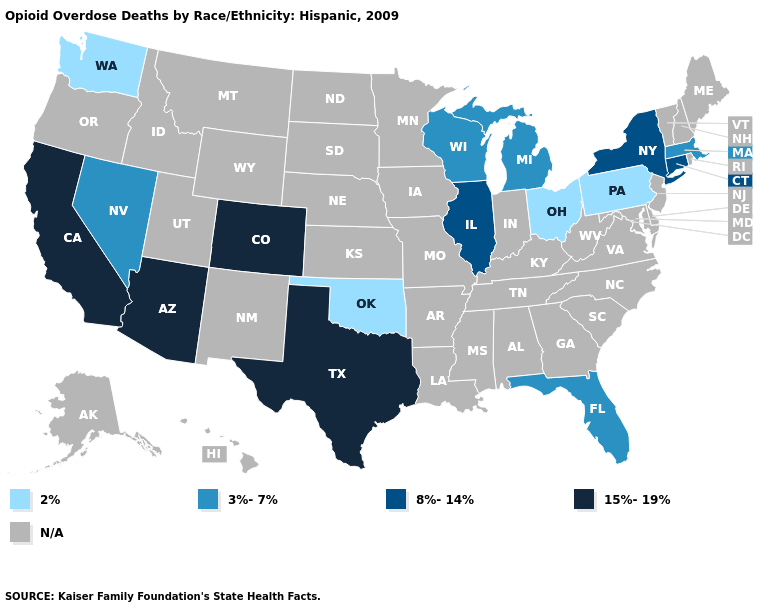Which states have the highest value in the USA?
Concise answer only. Arizona, California, Colorado, Texas. Which states have the lowest value in the USA?
Concise answer only. Ohio, Oklahoma, Pennsylvania, Washington. Name the states that have a value in the range 3%-7%?
Answer briefly. Florida, Massachusetts, Michigan, Nevada, Wisconsin. Among the states that border New Hampshire , which have the lowest value?
Give a very brief answer. Massachusetts. Name the states that have a value in the range 2%?
Short answer required. Ohio, Oklahoma, Pennsylvania, Washington. What is the value of Oregon?
Keep it brief. N/A. What is the lowest value in the USA?
Keep it brief. 2%. Name the states that have a value in the range N/A?
Short answer required. Alabama, Alaska, Arkansas, Delaware, Georgia, Hawaii, Idaho, Indiana, Iowa, Kansas, Kentucky, Louisiana, Maine, Maryland, Minnesota, Mississippi, Missouri, Montana, Nebraska, New Hampshire, New Jersey, New Mexico, North Carolina, North Dakota, Oregon, Rhode Island, South Carolina, South Dakota, Tennessee, Utah, Vermont, Virginia, West Virginia, Wyoming. Does Pennsylvania have the lowest value in the USA?
Answer briefly. Yes. What is the lowest value in the Northeast?
Give a very brief answer. 2%. What is the highest value in states that border Oklahoma?
Keep it brief. 15%-19%. Does California have the lowest value in the USA?
Quick response, please. No. What is the value of Michigan?
Keep it brief. 3%-7%. Does Pennsylvania have the lowest value in the Northeast?
Keep it brief. Yes. 